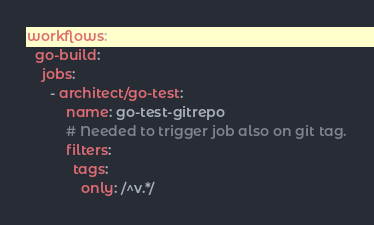Convert code to text. <code><loc_0><loc_0><loc_500><loc_500><_YAML_>
workflows:
  go-build:
    jobs:
      - architect/go-test:
          name: go-test-gitrepo
          # Needed to trigger job also on git tag.
          filters:
            tags:
              only: /^v.*/
</code> 